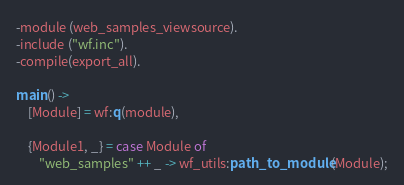Convert code to text. <code><loc_0><loc_0><loc_500><loc_500><_Erlang_>-module (web_samples_viewsource).
-include ("wf.inc").
-compile(export_all).

main() ->
	[Module] = wf:q(module),
	
	{Module1, _} = case Module of
		"web_samples" ++ _ -> wf_utils:path_to_module(Module);</code> 